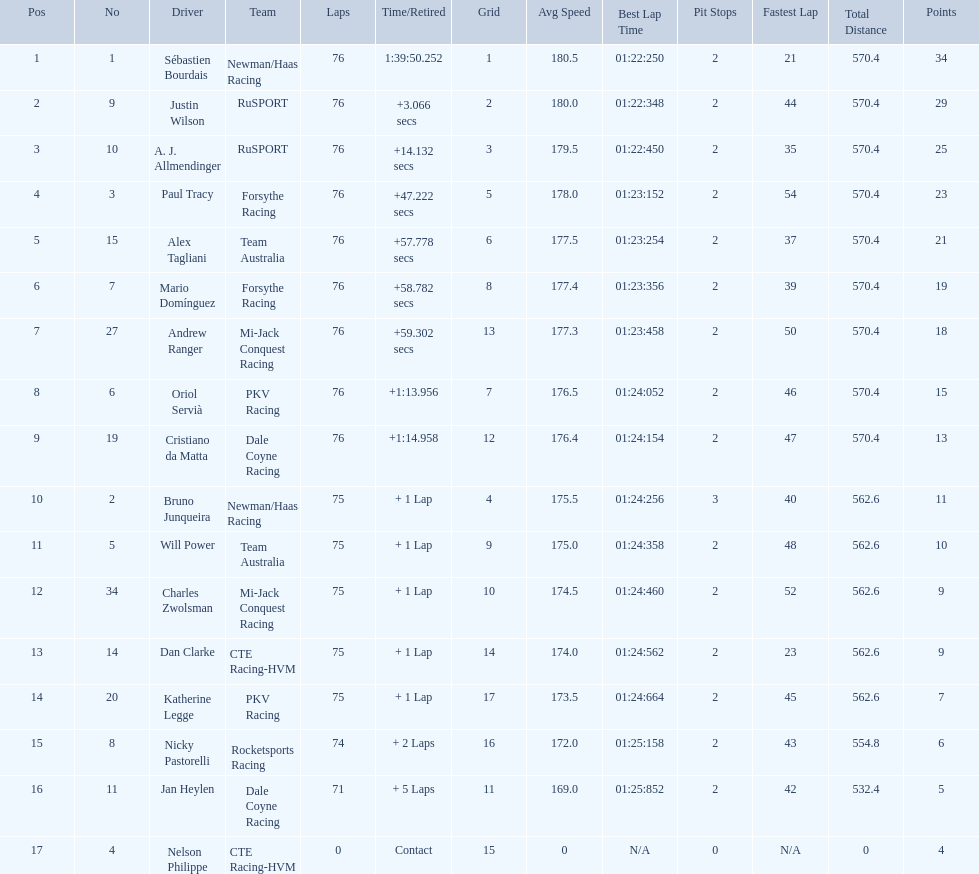Which driver has the least amount of points? Nelson Philippe. 